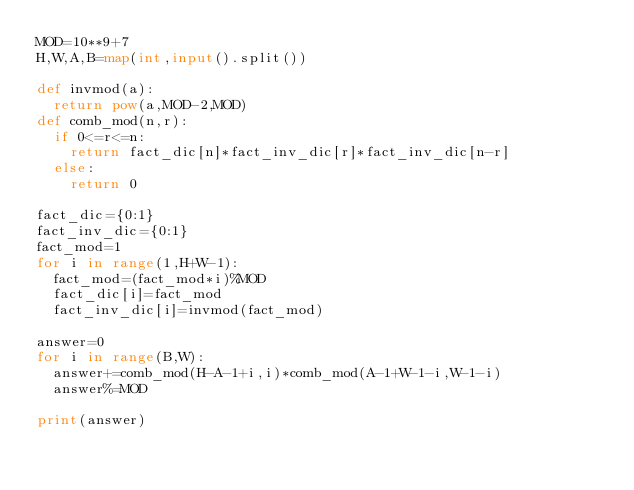<code> <loc_0><loc_0><loc_500><loc_500><_Python_>MOD=10**9+7
H,W,A,B=map(int,input().split())

def invmod(a):
  return pow(a,MOD-2,MOD)
def comb_mod(n,r):
  if 0<=r<=n:
    return fact_dic[n]*fact_inv_dic[r]*fact_inv_dic[n-r]
  else:
    return 0

fact_dic={0:1}
fact_inv_dic={0:1}
fact_mod=1
for i in range(1,H+W-1):
  fact_mod=(fact_mod*i)%MOD
  fact_dic[i]=fact_mod
  fact_inv_dic[i]=invmod(fact_mod)
  
answer=0
for i in range(B,W):
  answer+=comb_mod(H-A-1+i,i)*comb_mod(A-1+W-1-i,W-1-i)
  answer%=MOD
    
print(answer)</code> 